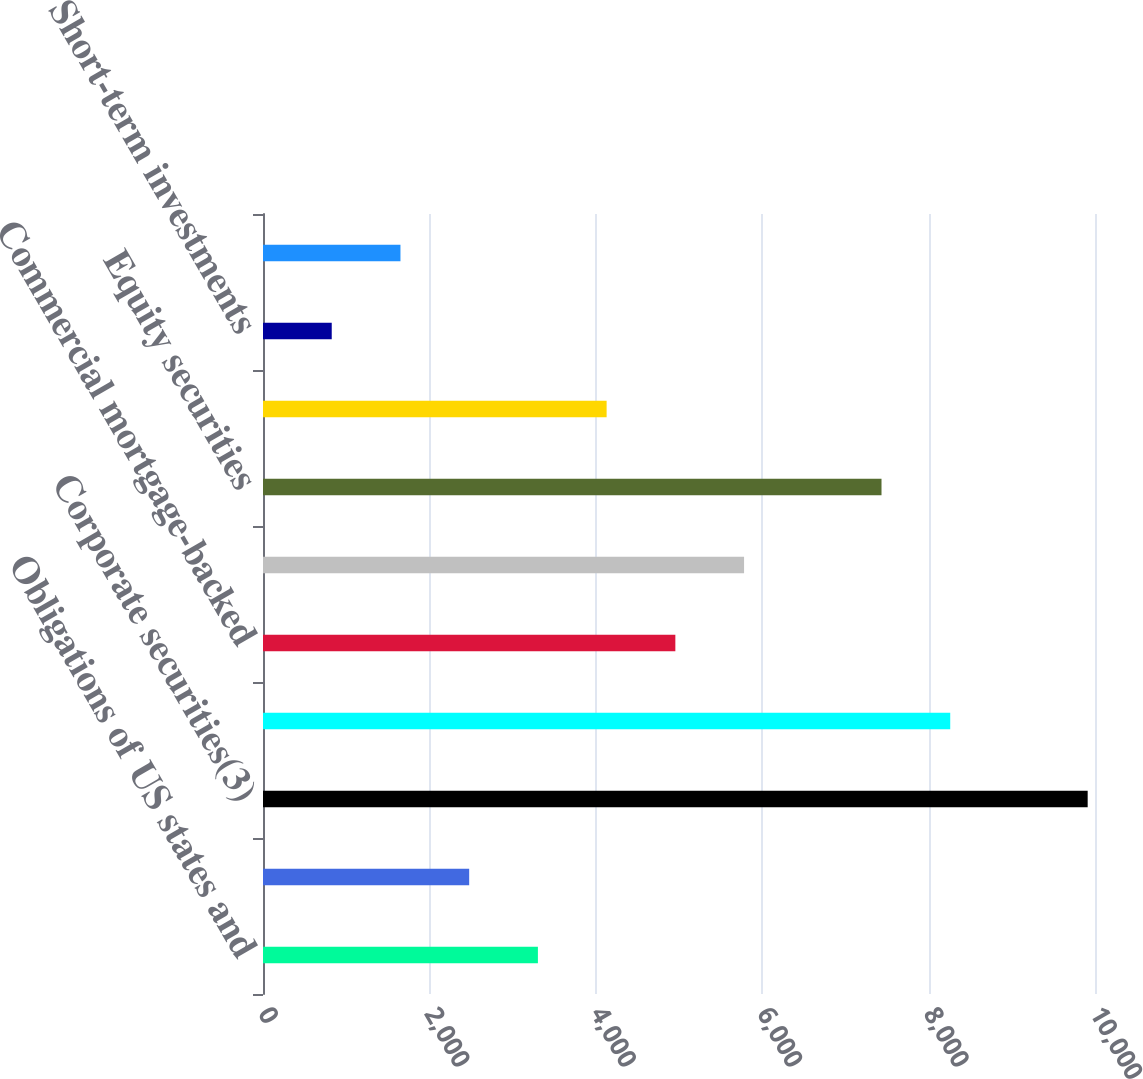Convert chart to OTSL. <chart><loc_0><loc_0><loc_500><loc_500><bar_chart><fcel>Obligations of US states and<fcel>Foreign government bonds<fcel>Corporate securities(3)<fcel>Asset-backed securities(4)<fcel>Commercial mortgage-backed<fcel>Residential mortgage-backed<fcel>Equity securities<fcel>Other long-term investments<fcel>Short-term investments<fcel>Other assets<nl><fcel>3304.12<fcel>2478.14<fcel>9911.96<fcel>8260<fcel>4956.08<fcel>5782.06<fcel>7434.02<fcel>4130.1<fcel>826.18<fcel>1652.16<nl></chart> 